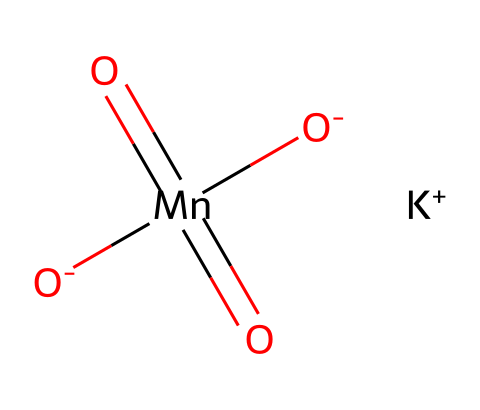What is the oxidation state of manganese in potassium permanganate? Manganese in this compound is represented by the symbol Mn, which is attached to four oxygen atoms. By counting the total oxidation states based on the oxidation numbers of the other elements, and knowing potassium (K) has a +1 oxidation state and each oxygen (O) typically has a -2 oxidation state (with two oxygens being -1 in this case), we can deduce that Mn has an oxidation state of +7 in order to balance the overall charge to zero.
Answer: +7 How many oxygen atoms are present in potassium permanganate? In the chemical structure, there are four oxygen atoms connected to the manganese atom indicated. By counting the number of oxygen symbols (O) in the structure, we confirm that there are four.
Answer: 4 What type of chemical bonding is present in potassium permanganate? The chemical structure represents ionic and covalent bonding. The potassium ion (K+) shows ionic bonding with the permanganate ion ([MnO4]-), which consists of covalent bonds between the manganese and oxygen atoms. Hence, the interactions include both types of bonds, but the predominant force in the entirety is ionic due to the potassium permanganate formation.
Answer: ionic and covalent What is the molecular formula of potassium permanganate? From the representation, we can see one potassium atom, one manganese atom, and four oxygen atoms. Together, these combine to give the molecular formula KMnO4, which is derived from the individual atoms present directly from the SMILES representation.
Answer: KMnO4 Is potassium permanganate a strong oxidizer? Potassium permanganate is known for its strong oxidizing properties, especially in water treatment processes. This knowledge comes from its high oxidation state of manganese (+7), which makes it highly reactive and capable of accepting electrons from other substances.
Answer: yes 